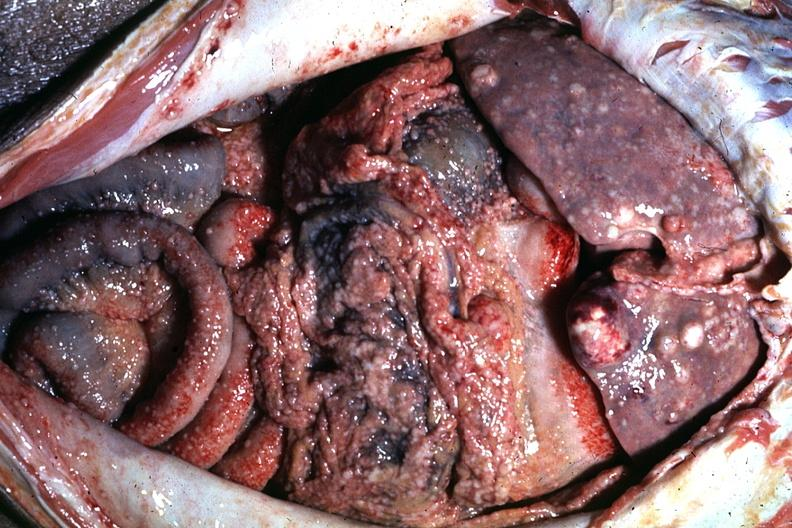s slices of liver and spleen typical tuberculous exudate is present on capsule of liver and spleen present?
Answer the question using a single word or phrase. No 